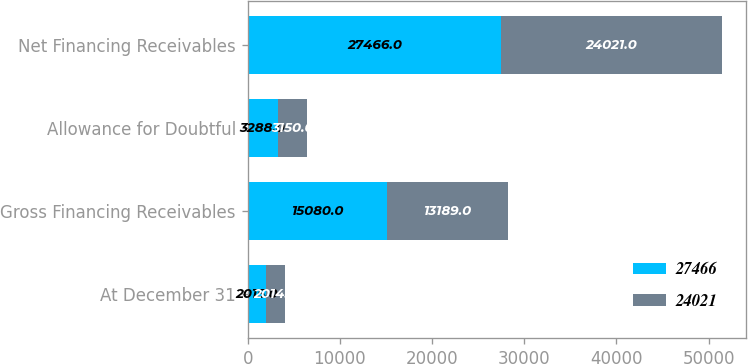Convert chart. <chart><loc_0><loc_0><loc_500><loc_500><stacked_bar_chart><ecel><fcel>At December 31<fcel>Gross Financing Receivables<fcel>Allowance for Doubtful<fcel>Net Financing Receivables<nl><fcel>27466<fcel>2015<fcel>15080<fcel>3288<fcel>27466<nl><fcel>24021<fcel>2014<fcel>13189<fcel>3150<fcel>24021<nl></chart> 